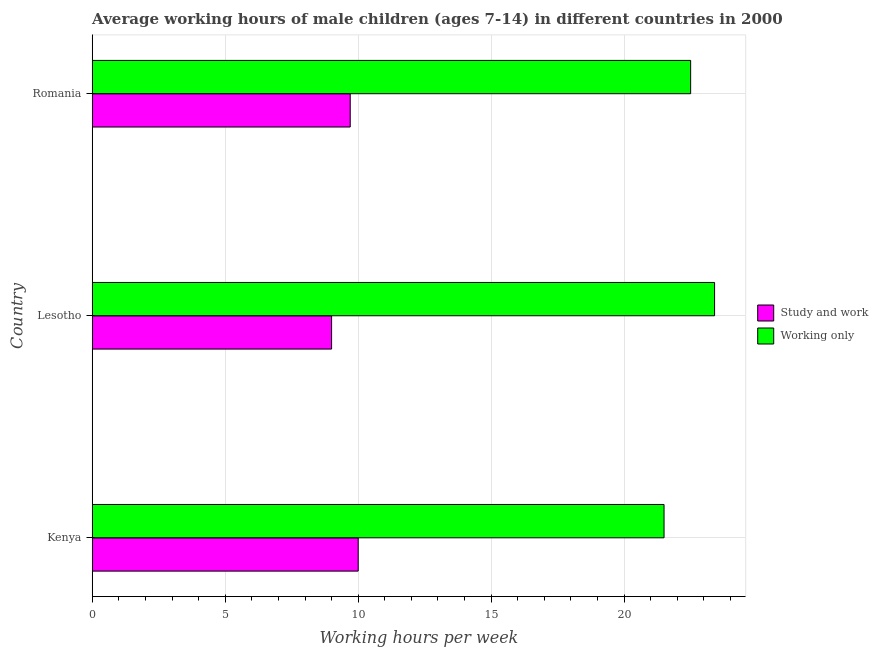How many different coloured bars are there?
Offer a terse response. 2. How many groups of bars are there?
Your response must be concise. 3. How many bars are there on the 3rd tick from the bottom?
Offer a very short reply. 2. What is the label of the 2nd group of bars from the top?
Provide a succinct answer. Lesotho. In how many cases, is the number of bars for a given country not equal to the number of legend labels?
Your response must be concise. 0. Across all countries, what is the maximum average working hour of children involved in study and work?
Your answer should be compact. 10. In which country was the average working hour of children involved in study and work maximum?
Offer a very short reply. Kenya. In which country was the average working hour of children involved in only work minimum?
Give a very brief answer. Kenya. What is the total average working hour of children involved in study and work in the graph?
Provide a succinct answer. 28.7. What is the difference between the average working hour of children involved in only work in Romania and the average working hour of children involved in study and work in Lesotho?
Ensure brevity in your answer.  13.5. What is the average average working hour of children involved in study and work per country?
Your answer should be compact. 9.57. In how many countries, is the average working hour of children involved in only work greater than 13 hours?
Give a very brief answer. 3. What is the ratio of the average working hour of children involved in only work in Kenya to that in Lesotho?
Make the answer very short. 0.92. Is the difference between the average working hour of children involved in study and work in Kenya and Romania greater than the difference between the average working hour of children involved in only work in Kenya and Romania?
Offer a very short reply. Yes. What is the difference between the highest and the second highest average working hour of children involved in only work?
Offer a terse response. 0.9. In how many countries, is the average working hour of children involved in study and work greater than the average average working hour of children involved in study and work taken over all countries?
Give a very brief answer. 2. Is the sum of the average working hour of children involved in study and work in Lesotho and Romania greater than the maximum average working hour of children involved in only work across all countries?
Offer a very short reply. No. What does the 1st bar from the top in Lesotho represents?
Offer a very short reply. Working only. What does the 2nd bar from the bottom in Romania represents?
Your answer should be compact. Working only. How many bars are there?
Give a very brief answer. 6. How many countries are there in the graph?
Offer a very short reply. 3. Are the values on the major ticks of X-axis written in scientific E-notation?
Your answer should be very brief. No. How are the legend labels stacked?
Your answer should be very brief. Vertical. What is the title of the graph?
Provide a short and direct response. Average working hours of male children (ages 7-14) in different countries in 2000. What is the label or title of the X-axis?
Provide a succinct answer. Working hours per week. What is the Working hours per week of Study and work in Kenya?
Ensure brevity in your answer.  10. What is the Working hours per week in Working only in Kenya?
Give a very brief answer. 21.5. What is the Working hours per week in Study and work in Lesotho?
Keep it short and to the point. 9. What is the Working hours per week of Working only in Lesotho?
Offer a very short reply. 23.4. What is the Working hours per week in Working only in Romania?
Provide a succinct answer. 22.5. Across all countries, what is the maximum Working hours per week of Working only?
Provide a succinct answer. 23.4. Across all countries, what is the minimum Working hours per week in Study and work?
Keep it short and to the point. 9. What is the total Working hours per week in Study and work in the graph?
Keep it short and to the point. 28.7. What is the total Working hours per week of Working only in the graph?
Your answer should be very brief. 67.4. What is the difference between the Working hours per week of Study and work in Kenya and that in Romania?
Keep it short and to the point. 0.3. What is the difference between the Working hours per week of Study and work in Lesotho and that in Romania?
Your response must be concise. -0.7. What is the difference between the Working hours per week in Working only in Lesotho and that in Romania?
Your response must be concise. 0.9. What is the difference between the Working hours per week of Study and work in Kenya and the Working hours per week of Working only in Lesotho?
Provide a short and direct response. -13.4. What is the difference between the Working hours per week in Study and work in Lesotho and the Working hours per week in Working only in Romania?
Keep it short and to the point. -13.5. What is the average Working hours per week of Study and work per country?
Offer a terse response. 9.57. What is the average Working hours per week in Working only per country?
Ensure brevity in your answer.  22.47. What is the difference between the Working hours per week of Study and work and Working hours per week of Working only in Lesotho?
Your response must be concise. -14.4. What is the ratio of the Working hours per week in Study and work in Kenya to that in Lesotho?
Your response must be concise. 1.11. What is the ratio of the Working hours per week of Working only in Kenya to that in Lesotho?
Your response must be concise. 0.92. What is the ratio of the Working hours per week in Study and work in Kenya to that in Romania?
Offer a terse response. 1.03. What is the ratio of the Working hours per week of Working only in Kenya to that in Romania?
Keep it short and to the point. 0.96. What is the ratio of the Working hours per week in Study and work in Lesotho to that in Romania?
Offer a terse response. 0.93. What is the ratio of the Working hours per week of Working only in Lesotho to that in Romania?
Give a very brief answer. 1.04. What is the difference between the highest and the second highest Working hours per week of Working only?
Ensure brevity in your answer.  0.9. What is the difference between the highest and the lowest Working hours per week in Working only?
Provide a short and direct response. 1.9. 